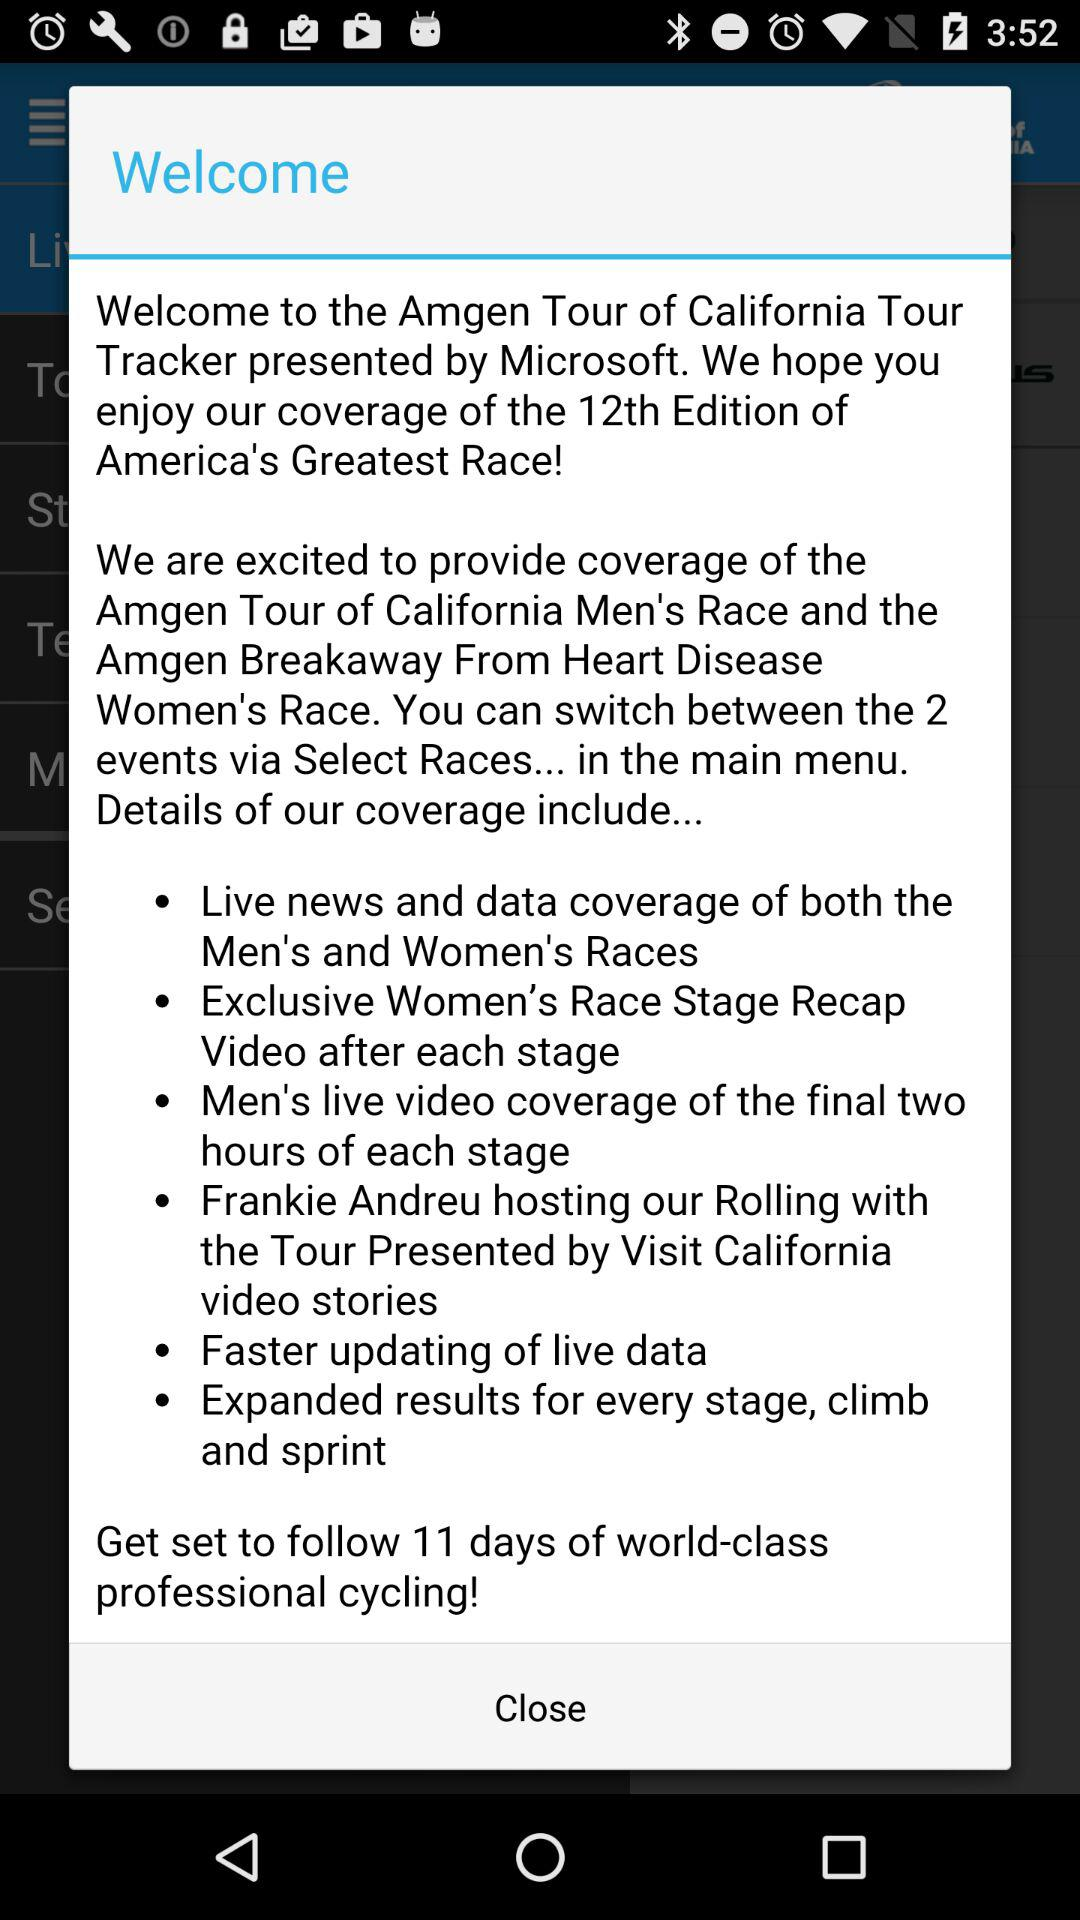How many events are covered by the app?
Answer the question using a single word or phrase. 2 